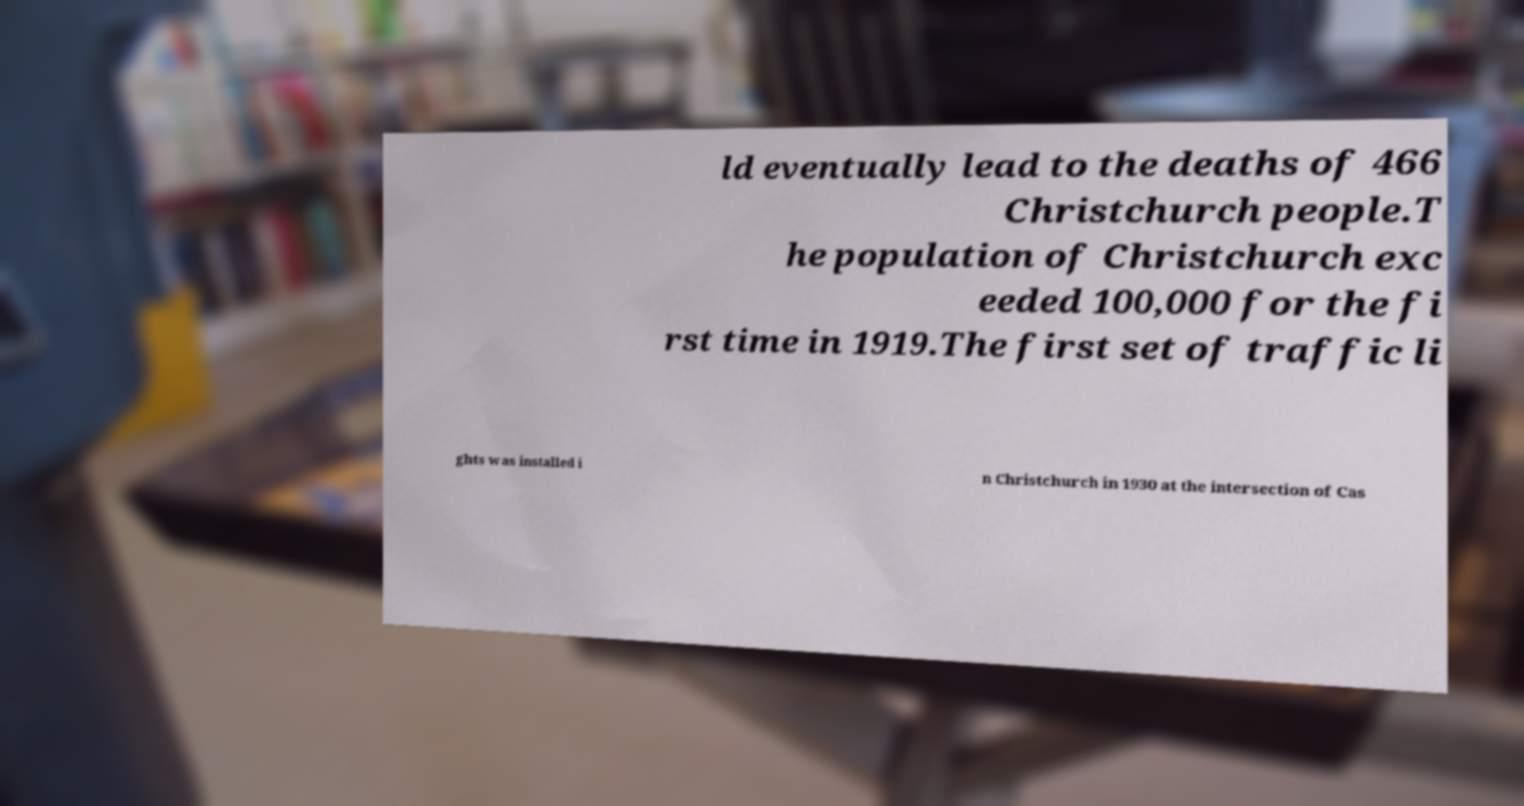Please read and relay the text visible in this image. What does it say? ld eventually lead to the deaths of 466 Christchurch people.T he population of Christchurch exc eeded 100,000 for the fi rst time in 1919.The first set of traffic li ghts was installed i n Christchurch in 1930 at the intersection of Cas 